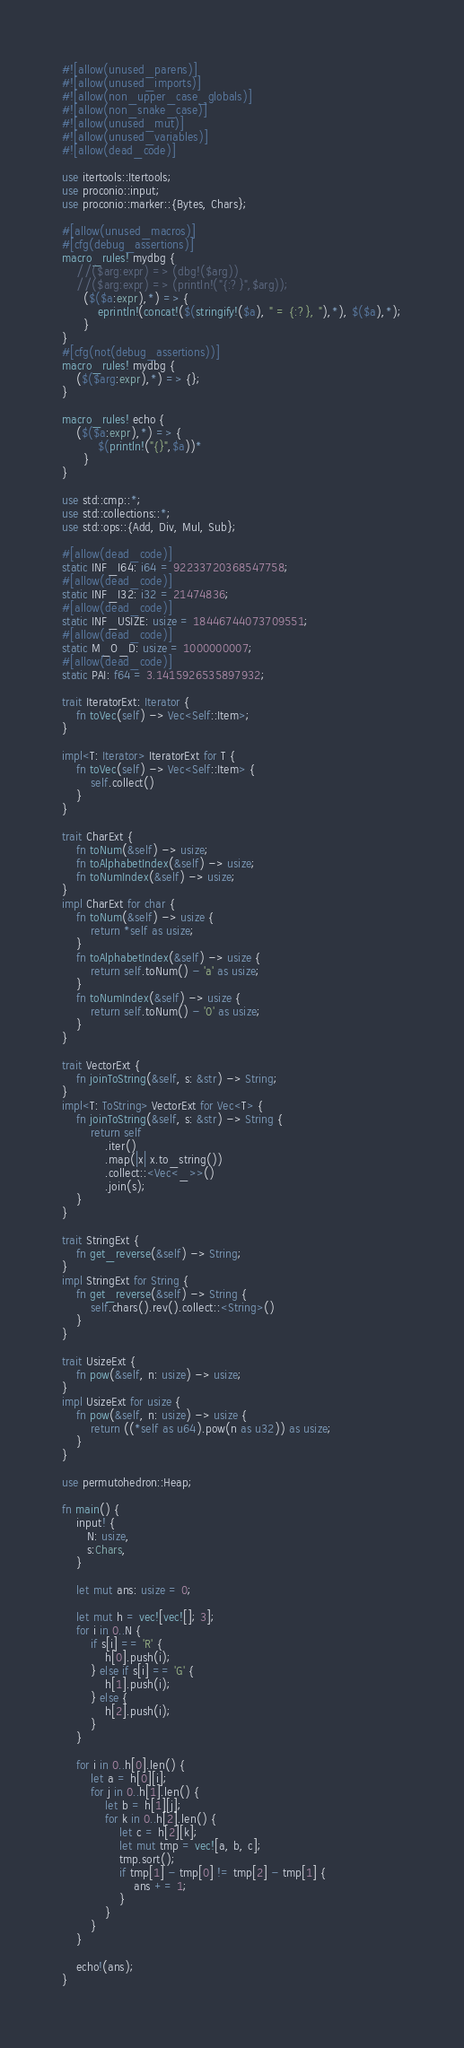<code> <loc_0><loc_0><loc_500><loc_500><_Rust_>#![allow(unused_parens)]
#![allow(unused_imports)]
#![allow(non_upper_case_globals)]
#![allow(non_snake_case)]
#![allow(unused_mut)]
#![allow(unused_variables)]
#![allow(dead_code)]

use itertools::Itertools;
use proconio::input;
use proconio::marker::{Bytes, Chars};

#[allow(unused_macros)]
#[cfg(debug_assertions)]
macro_rules! mydbg {
    //($arg:expr) => (dbg!($arg))
    //($arg:expr) => (println!("{:?}",$arg));
      ($($a:expr),*) => {
          eprintln!(concat!($(stringify!($a), " = {:?}, "),*), $($a),*);
      }
}
#[cfg(not(debug_assertions))]
macro_rules! mydbg {
    ($($arg:expr),*) => {};
}

macro_rules! echo {
    ($($a:expr),*) => {
          $(println!("{}",$a))*
      }
}

use std::cmp::*;
use std::collections::*;
use std::ops::{Add, Div, Mul, Sub};

#[allow(dead_code)]
static INF_I64: i64 = 92233720368547758;
#[allow(dead_code)]
static INF_I32: i32 = 21474836;
#[allow(dead_code)]
static INF_USIZE: usize = 18446744073709551;
#[allow(dead_code)]
static M_O_D: usize = 1000000007;
#[allow(dead_code)]
static PAI: f64 = 3.1415926535897932;

trait IteratorExt: Iterator {
    fn toVec(self) -> Vec<Self::Item>;
}

impl<T: Iterator> IteratorExt for T {
    fn toVec(self) -> Vec<Self::Item> {
        self.collect()
    }
}

trait CharExt {
    fn toNum(&self) -> usize;
    fn toAlphabetIndex(&self) -> usize;
    fn toNumIndex(&self) -> usize;
}
impl CharExt for char {
    fn toNum(&self) -> usize {
        return *self as usize;
    }
    fn toAlphabetIndex(&self) -> usize {
        return self.toNum() - 'a' as usize;
    }
    fn toNumIndex(&self) -> usize {
        return self.toNum() - '0' as usize;
    }
}

trait VectorExt {
    fn joinToString(&self, s: &str) -> String;
}
impl<T: ToString> VectorExt for Vec<T> {
    fn joinToString(&self, s: &str) -> String {
        return self
            .iter()
            .map(|x| x.to_string())
            .collect::<Vec<_>>()
            .join(s);
    }
}

trait StringExt {
    fn get_reverse(&self) -> String;
}
impl StringExt for String {
    fn get_reverse(&self) -> String {
        self.chars().rev().collect::<String>()
    }
}

trait UsizeExt {
    fn pow(&self, n: usize) -> usize;
}
impl UsizeExt for usize {
    fn pow(&self, n: usize) -> usize {
        return ((*self as u64).pow(n as u32)) as usize;
    }
}

use permutohedron::Heap;

fn main() {
    input! {
       N: usize,
       s:Chars,
    }

    let mut ans: usize = 0;

    let mut h = vec![vec![]; 3];
    for i in 0..N {
        if s[i] == 'R' {
            h[0].push(i);
        } else if s[i] == 'G' {
            h[1].push(i);
        } else {
            h[2].push(i);
        }
    }

    for i in 0..h[0].len() {
        let a = h[0][i];
        for j in 0..h[1].len() {
            let b = h[1][j];
            for k in 0..h[2].len() {
                let c = h[2][k];
                let mut tmp = vec![a, b, c];
                tmp.sort();
                if tmp[1] - tmp[0] != tmp[2] - tmp[1] {
                    ans += 1;
                }
            }
        }
    }

    echo!(ans);
}
</code> 